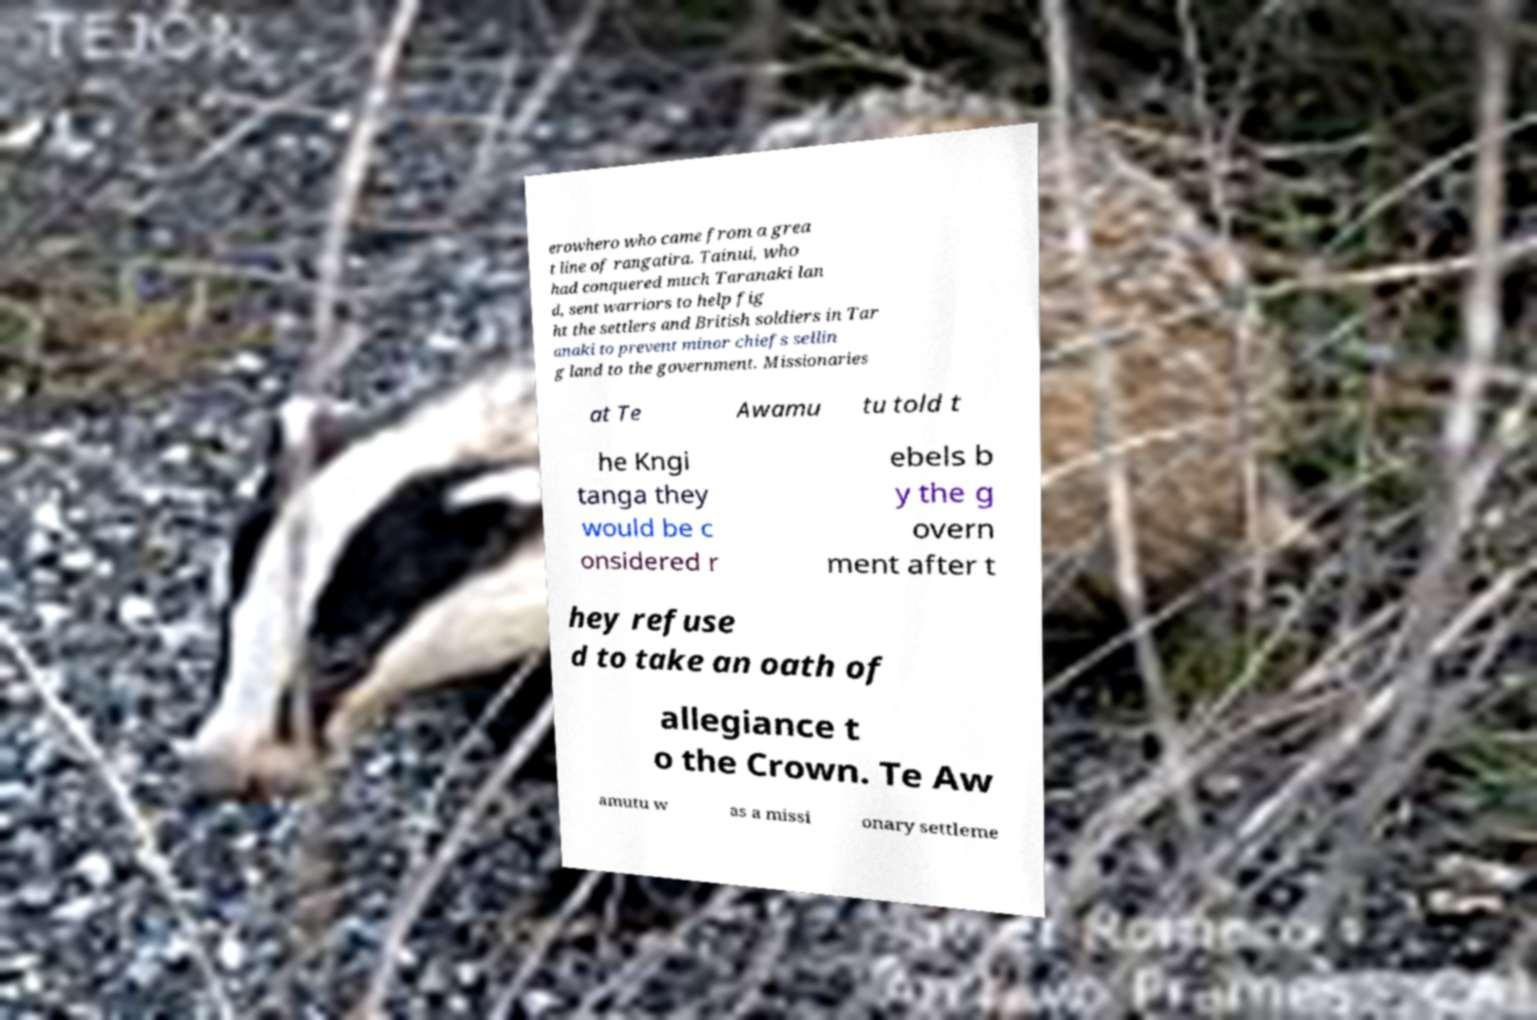There's text embedded in this image that I need extracted. Can you transcribe it verbatim? erowhero who came from a grea t line of rangatira. Tainui, who had conquered much Taranaki lan d, sent warriors to help fig ht the settlers and British soldiers in Tar anaki to prevent minor chiefs sellin g land to the government. Missionaries at Te Awamu tu told t he Kngi tanga they would be c onsidered r ebels b y the g overn ment after t hey refuse d to take an oath of allegiance t o the Crown. Te Aw amutu w as a missi onary settleme 